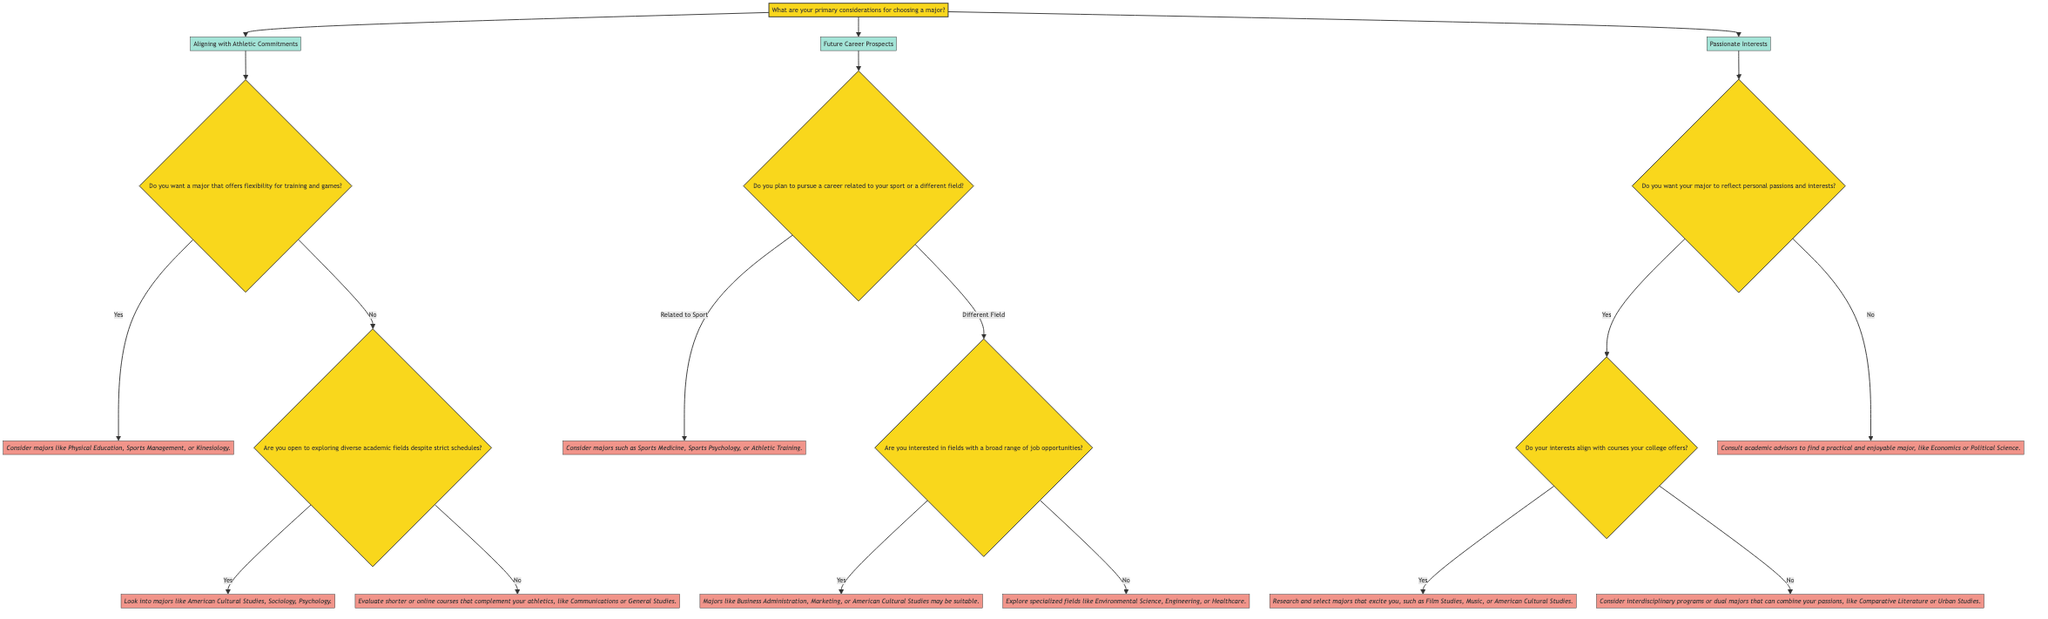What are the three primary considerations for choosing a major? The diagram explicitly lists the three main considerations at the first level: Aligning with Athletic Commitments, Future Career Prospects, and Passionate Interests.
Answer: Aligning with Athletic Commitments, Future Career Prospects, Passionate Interests How many branches stem from the first question? The first question has three branches leading to each of the main considerations regarding choosing a major. These branches include Aligning with Athletic Commitments, Future Career Prospects, and Passionate Interests.
Answer: Three If choosing "Aligning with Athletic Commitments," what is the next question? Following the selection of Aligning with Athletic Commitments, the next question posed is about flexibility for training and games. This is a direct follow-up to understand how athletic commitments are prioritized in choosing a major.
Answer: Do you want a major that offers flexibility for training and games? What majors are suggested if the answer to flexibility in training is "Yes"? If the answer to the flexibility question is "Yes," the conclusion drawn suggests that one should consider majors like Physical Education, Sports Management, or Kinesiology. This is directly indicated in the diagram as suitable options for those seeking flexible schedules.
Answer: Consider majors like Physical Education, Sports Management, or Kinesiology What conclusion is reached if the answer to “Are you open to exploring diverse academic fields despite strict schedules?” is "No"? If the response to the question about exploring diverse academic fields is "No," the diagram concludes with evaluating shorter or online courses that complement athletics, such as Communications or General Studies. This highlights an alternative pathway that accommodates strict schedules.
Answer: Evaluate shorter or online courses that complement your athletics, like Communications or General Studies What is the suggested major if a student desires to reflect their personal passions and interests in their choice? The choice to reflect personal passions leads to a follow-up question regarding alignment with college courses. If they affirmatively align, the suggested majors include Film Studies, Music, or American Cultural Studies, indicated for excitement and engagement.
Answer: Research and select majors that excite you, such as Film Studies, Music, or American Cultural Studies What should a student do if their interests do not align with the courses their college offers? If a student's interests do not align with available courses, the decision tree suggests considering interdisciplinary programs or dual majors that can combine passions, which allows them to pursue diverse academic interests.
Answer: Consider interdisciplinary programs or dual majors that can combine your passions, like Comparative Literature or Urban Studies Which majors are recommended for someone planning to pursue a career related to their sport? If a student intends to pursue a career related to their sport, the diagram concludes with recommending majors such as Sports Medicine, Sports Psychology, or Athletic Training. This clearly outlines career-oriented paths related to athletics.
Answer: Consider majors such as Sports Medicine, Sports Psychology, or Athletic Training 